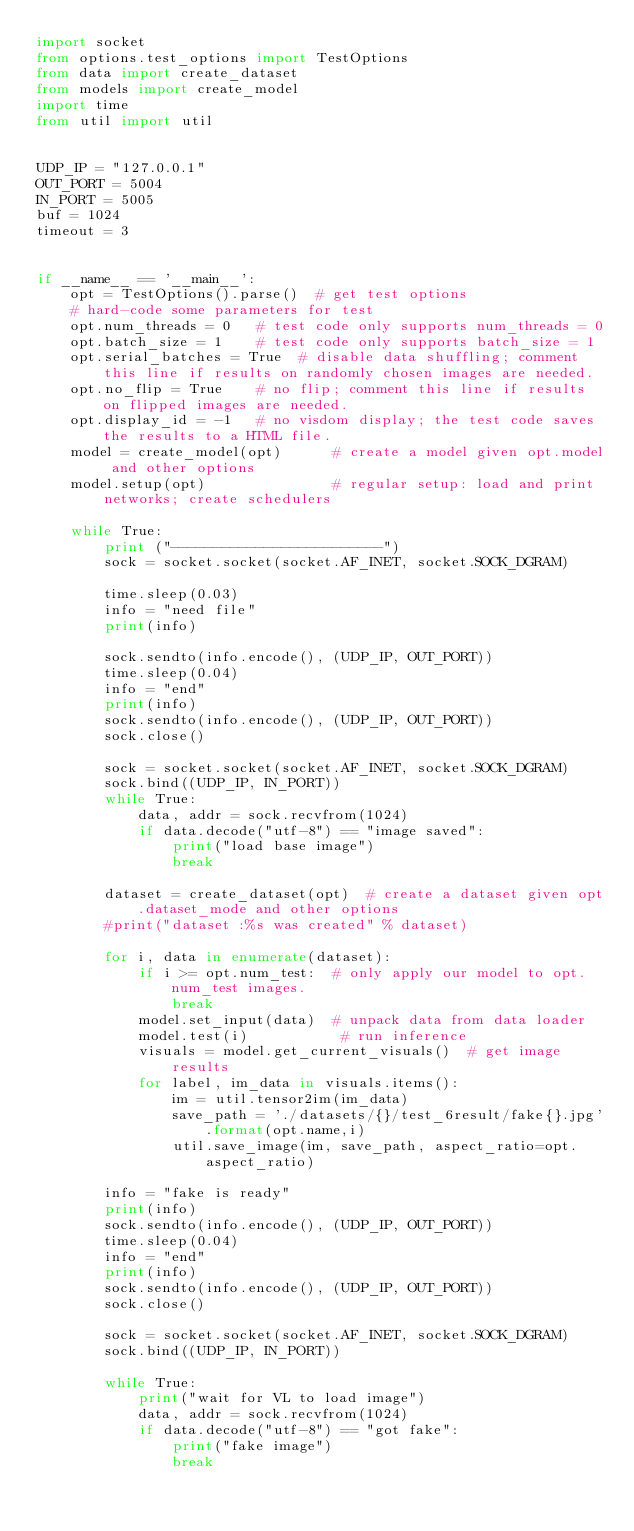<code> <loc_0><loc_0><loc_500><loc_500><_Python_>import socket
from options.test_options import TestOptions
from data import create_dataset
from models import create_model
import time
from util import util


UDP_IP = "127.0.0.1"
OUT_PORT = 5004
IN_PORT = 5005
buf = 1024
timeout = 3


if __name__ == '__main__':
    opt = TestOptions().parse()  # get test options
    # hard-code some parameters for test
    opt.num_threads = 0   # test code only supports num_threads = 0
    opt.batch_size = 1    # test code only supports batch_size = 1
    opt.serial_batches = True  # disable data shuffling; comment this line if results on randomly chosen images are needed.
    opt.no_flip = True    # no flip; comment this line if results on flipped images are needed.
    opt.display_id = -1   # no visdom display; the test code saves the results to a HTML file.
    model = create_model(opt)      # create a model given opt.model and other options
    model.setup(opt)               # regular setup: load and print networks; create schedulers

    while True:
        print ("-------------------------")
        sock = socket.socket(socket.AF_INET, socket.SOCK_DGRAM)

        time.sleep(0.03)
        info = "need file"
        print(info)

        sock.sendto(info.encode(), (UDP_IP, OUT_PORT))
        time.sleep(0.04)
        info = "end"
        print(info)
        sock.sendto(info.encode(), (UDP_IP, OUT_PORT))
        sock.close()

        sock = socket.socket(socket.AF_INET, socket.SOCK_DGRAM)
        sock.bind((UDP_IP, IN_PORT))
        while True:
            data, addr = sock.recvfrom(1024)
            if data.decode("utf-8") == "image saved":
                print("load base image")
                break

        dataset = create_dataset(opt)  # create a dataset given opt.dataset_mode and other options
        #print("dataset :%s was created" % dataset)

        for i, data in enumerate(dataset):
            if i >= opt.num_test:  # only apply our model to opt.num_test images.
                break
            model.set_input(data)  # unpack data from data loader
            model.test(i)           # run inference
            visuals = model.get_current_visuals()  # get image results
            for label, im_data in visuals.items():
                im = util.tensor2im(im_data)
                save_path = './datasets/{}/test_6result/fake{}.jpg'.format(opt.name,i)
                util.save_image(im, save_path, aspect_ratio=opt.aspect_ratio)

        info = "fake is ready"
        print(info)
        sock.sendto(info.encode(), (UDP_IP, OUT_PORT))
        time.sleep(0.04)
        info = "end"
        print(info)
        sock.sendto(info.encode(), (UDP_IP, OUT_PORT))
        sock.close()

        sock = socket.socket(socket.AF_INET, socket.SOCK_DGRAM)
        sock.bind((UDP_IP, IN_PORT))

        while True:
            print("wait for VL to load image")
            data, addr = sock.recvfrom(1024)
            if data.decode("utf-8") == "got fake":
                print("fake image")
                break
</code> 